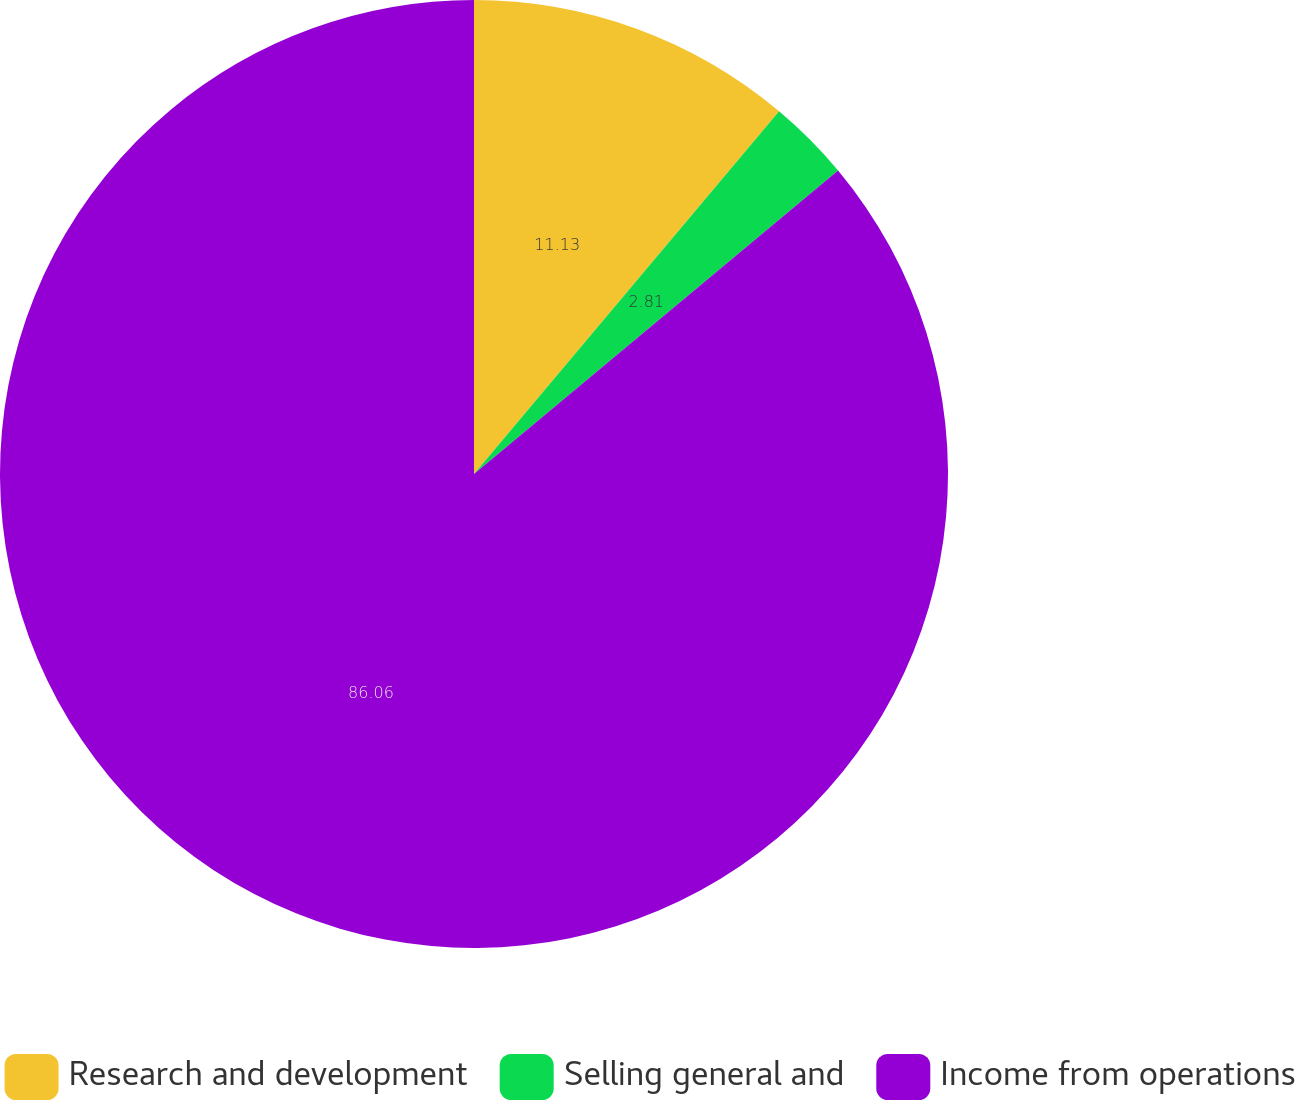<chart> <loc_0><loc_0><loc_500><loc_500><pie_chart><fcel>Research and development<fcel>Selling general and<fcel>Income from operations<nl><fcel>11.13%<fcel>2.81%<fcel>86.06%<nl></chart> 